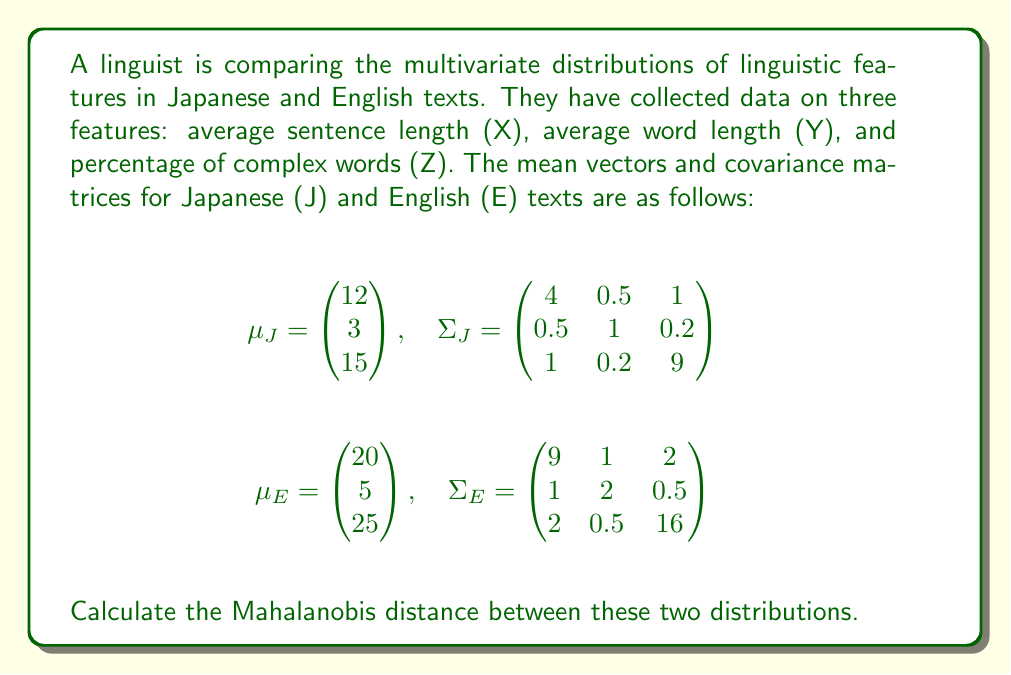Could you help me with this problem? To calculate the Mahalanobis distance between two multivariate distributions, we'll follow these steps:

1) The Mahalanobis distance formula is:
   $$D^2 = (\mu_1 - \mu_2)^T S^{-1} (\mu_1 - \mu_2)$$
   where $S = \frac{1}{2}(\Sigma_1 + \Sigma_2)$

2) First, calculate the difference between mean vectors:
   $$\mu_E - \mu_J = \begin{pmatrix} 20 \\ 5 \\ 25 \end{pmatrix} - \begin{pmatrix} 12 \\ 3 \\ 15 \end{pmatrix} = \begin{pmatrix} 8 \\ 2 \\ 10 \end{pmatrix}$$

3) Calculate $S$:
   $$S = \frac{1}{2}(\Sigma_J + \Sigma_E) = \frac{1}{2}\begin{pmatrix} 13 & 1.5 & 3 \\ 1.5 & 3 & 0.7 \\ 3 & 0.7 & 25 \end{pmatrix}$$

4) Calculate $S^{-1}$:
   $$S^{-1} \approx \begin{pmatrix} 0.0815 & -0.0407 & -0.0098 \\ -0.0407 & 0.3540 & -0.0076 \\ -0.0098 & -0.0076 & 0.0424 \end{pmatrix}$$

5) Now, calculate $D^2$:
   $$D^2 = \begin{pmatrix} 8 & 2 & 10 \end{pmatrix} \begin{pmatrix} 0.0815 & -0.0407 & -0.0098 \\ -0.0407 & 0.3540 & -0.0076 \\ -0.0098 & -0.0076 & 0.0424 \end{pmatrix} \begin{pmatrix} 8 \\ 2 \\ 10 \end{pmatrix}$$

6) Multiply the matrices:
   $$D^2 = \begin{pmatrix} 0.3944 & 0.6364 & 0.3912 \end{pmatrix} \begin{pmatrix} 8 \\ 2 \\ 10 \end{pmatrix} = 7.9136$$

7) Take the square root to get the Mahalanobis distance:
   $$D = \sqrt{7.9136} \approx 2.8131$$
Answer: 2.8131 